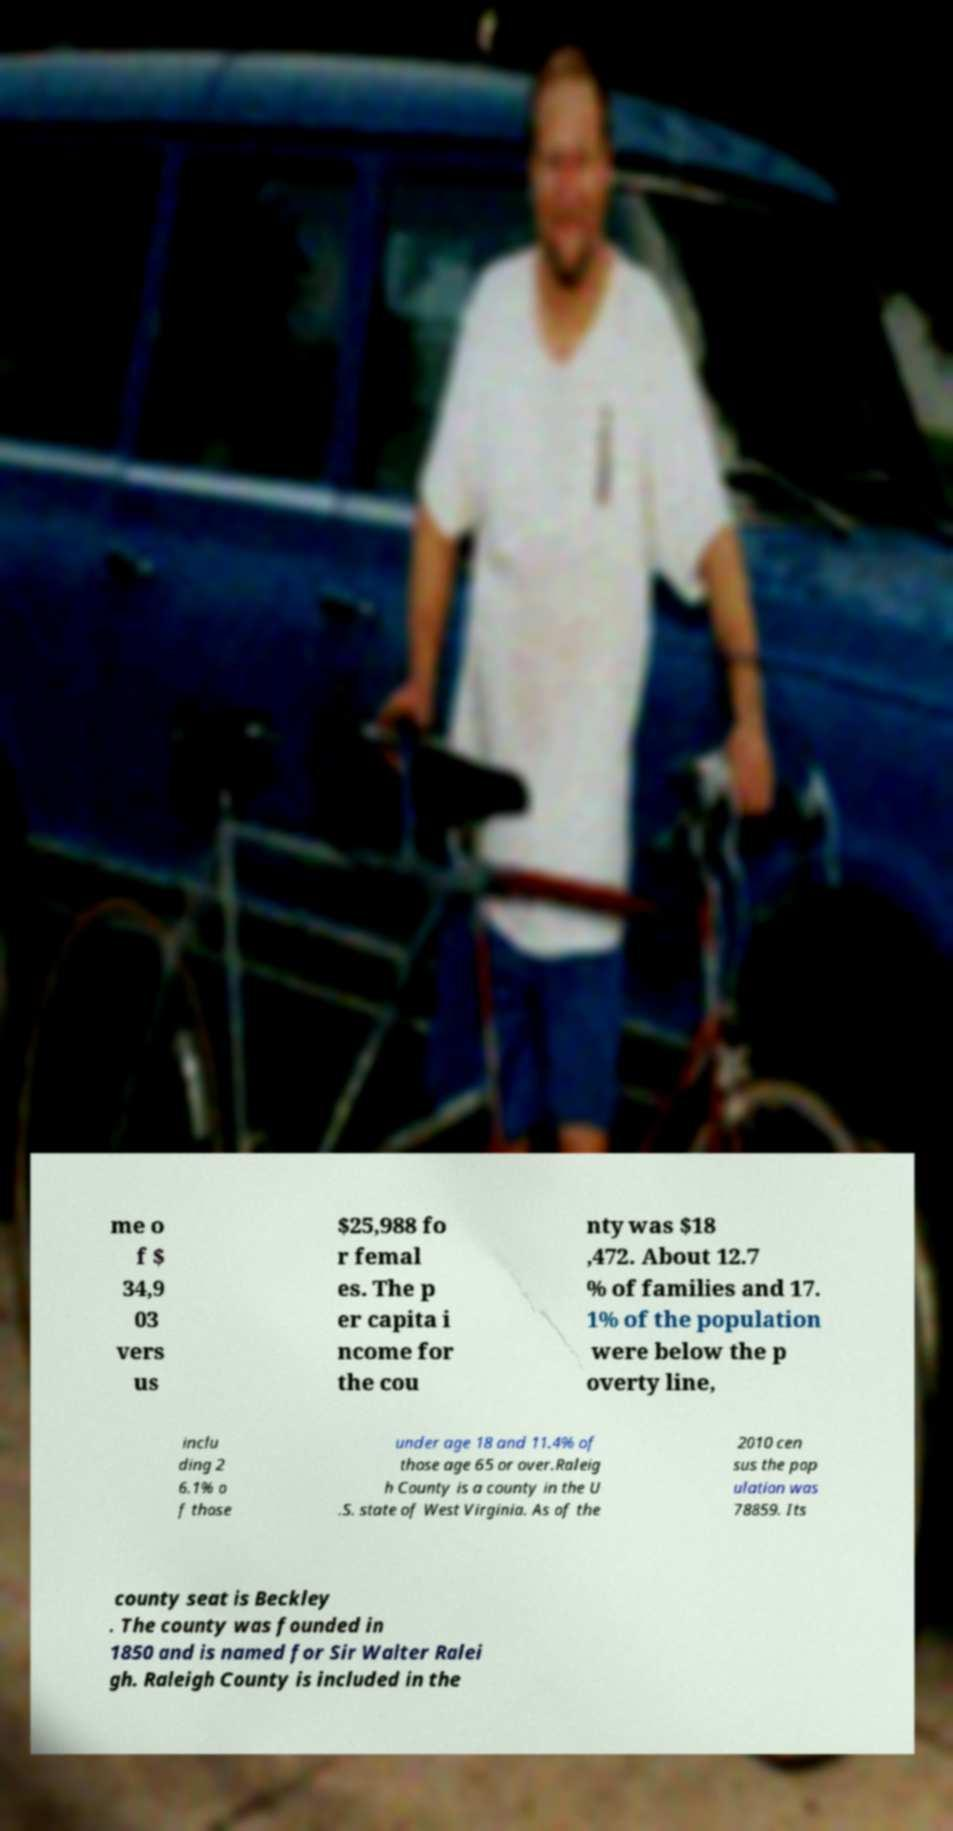Can you accurately transcribe the text from the provided image for me? me o f $ 34,9 03 vers us $25,988 fo r femal es. The p er capita i ncome for the cou nty was $18 ,472. About 12.7 % of families and 17. 1% of the population were below the p overty line, inclu ding 2 6.1% o f those under age 18 and 11.4% of those age 65 or over.Raleig h County is a county in the U .S. state of West Virginia. As of the 2010 cen sus the pop ulation was 78859. Its county seat is Beckley . The county was founded in 1850 and is named for Sir Walter Ralei gh. Raleigh County is included in the 